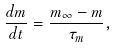Convert formula to latex. <formula><loc_0><loc_0><loc_500><loc_500>\frac { d m } { d t } = \frac { m _ { \infty } - m } { \tau _ { m } } ,</formula> 